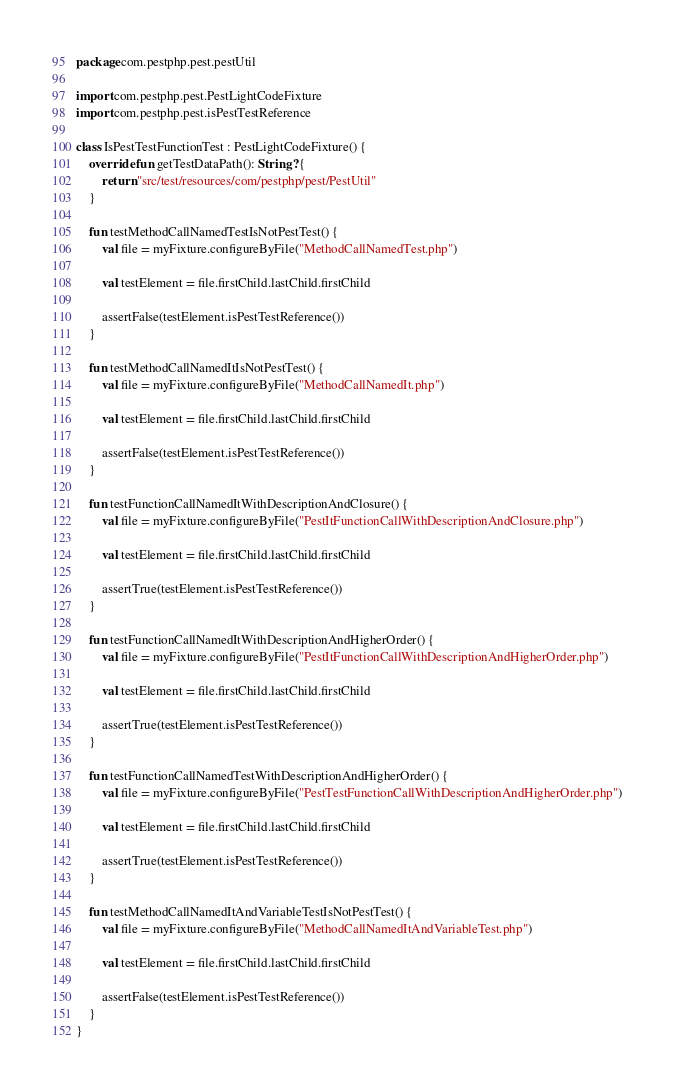Convert code to text. <code><loc_0><loc_0><loc_500><loc_500><_Kotlin_>package com.pestphp.pest.pestUtil

import com.pestphp.pest.PestLightCodeFixture
import com.pestphp.pest.isPestTestReference

class IsPestTestFunctionTest : PestLightCodeFixture() {
    override fun getTestDataPath(): String? {
        return "src/test/resources/com/pestphp/pest/PestUtil"
    }

    fun testMethodCallNamedTestIsNotPestTest() {
        val file = myFixture.configureByFile("MethodCallNamedTest.php")

        val testElement = file.firstChild.lastChild.firstChild

        assertFalse(testElement.isPestTestReference())
    }

    fun testMethodCallNamedItIsNotPestTest() {
        val file = myFixture.configureByFile("MethodCallNamedIt.php")

        val testElement = file.firstChild.lastChild.firstChild

        assertFalse(testElement.isPestTestReference())
    }

    fun testFunctionCallNamedItWithDescriptionAndClosure() {
        val file = myFixture.configureByFile("PestItFunctionCallWithDescriptionAndClosure.php")

        val testElement = file.firstChild.lastChild.firstChild

        assertTrue(testElement.isPestTestReference())
    }

    fun testFunctionCallNamedItWithDescriptionAndHigherOrder() {
        val file = myFixture.configureByFile("PestItFunctionCallWithDescriptionAndHigherOrder.php")

        val testElement = file.firstChild.lastChild.firstChild

        assertTrue(testElement.isPestTestReference())
    }

    fun testFunctionCallNamedTestWithDescriptionAndHigherOrder() {
        val file = myFixture.configureByFile("PestTestFunctionCallWithDescriptionAndHigherOrder.php")

        val testElement = file.firstChild.lastChild.firstChild

        assertTrue(testElement.isPestTestReference())
    }

    fun testMethodCallNamedItAndVariableTestIsNotPestTest() {
        val file = myFixture.configureByFile("MethodCallNamedItAndVariableTest.php")

        val testElement = file.firstChild.lastChild.firstChild

        assertFalse(testElement.isPestTestReference())
    }
}
</code> 